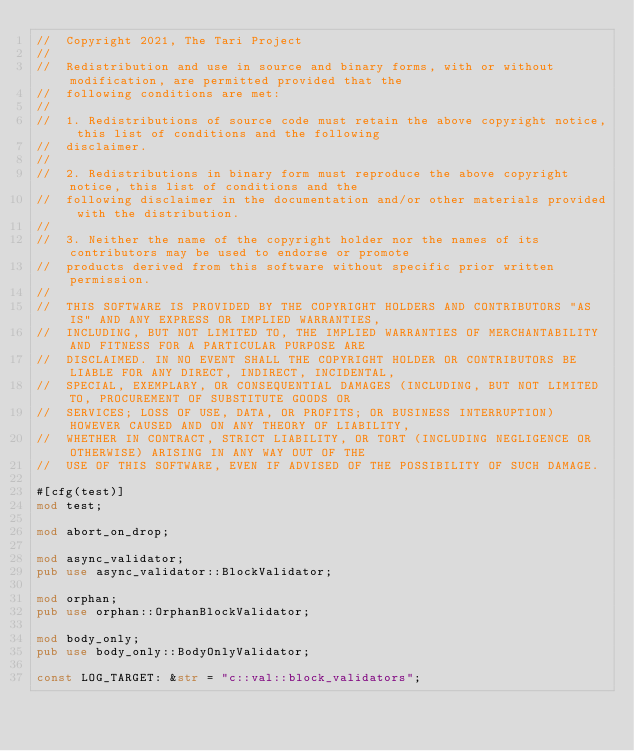Convert code to text. <code><loc_0><loc_0><loc_500><loc_500><_Rust_>//  Copyright 2021, The Tari Project
//
//  Redistribution and use in source and binary forms, with or without modification, are permitted provided that the
//  following conditions are met:
//
//  1. Redistributions of source code must retain the above copyright notice, this list of conditions and the following
//  disclaimer.
//
//  2. Redistributions in binary form must reproduce the above copyright notice, this list of conditions and the
//  following disclaimer in the documentation and/or other materials provided with the distribution.
//
//  3. Neither the name of the copyright holder nor the names of its contributors may be used to endorse or promote
//  products derived from this software without specific prior written permission.
//
//  THIS SOFTWARE IS PROVIDED BY THE COPYRIGHT HOLDERS AND CONTRIBUTORS "AS IS" AND ANY EXPRESS OR IMPLIED WARRANTIES,
//  INCLUDING, BUT NOT LIMITED TO, THE IMPLIED WARRANTIES OF MERCHANTABILITY AND FITNESS FOR A PARTICULAR PURPOSE ARE
//  DISCLAIMED. IN NO EVENT SHALL THE COPYRIGHT HOLDER OR CONTRIBUTORS BE LIABLE FOR ANY DIRECT, INDIRECT, INCIDENTAL,
//  SPECIAL, EXEMPLARY, OR CONSEQUENTIAL DAMAGES (INCLUDING, BUT NOT LIMITED TO, PROCUREMENT OF SUBSTITUTE GOODS OR
//  SERVICES; LOSS OF USE, DATA, OR PROFITS; OR BUSINESS INTERRUPTION) HOWEVER CAUSED AND ON ANY THEORY OF LIABILITY,
//  WHETHER IN CONTRACT, STRICT LIABILITY, OR TORT (INCLUDING NEGLIGENCE OR OTHERWISE) ARISING IN ANY WAY OUT OF THE
//  USE OF THIS SOFTWARE, EVEN IF ADVISED OF THE POSSIBILITY OF SUCH DAMAGE.

#[cfg(test)]
mod test;

mod abort_on_drop;

mod async_validator;
pub use async_validator::BlockValidator;

mod orphan;
pub use orphan::OrphanBlockValidator;

mod body_only;
pub use body_only::BodyOnlyValidator;

const LOG_TARGET: &str = "c::val::block_validators";
</code> 